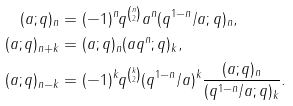Convert formula to latex. <formula><loc_0><loc_0><loc_500><loc_500>( a ; q ) _ { n } & = ( - 1 ) ^ { n } q ^ { \binom { n } { 2 } } a ^ { n } ( q ^ { 1 - n } / a ; q ) _ { n } , \\ ( a ; q ) _ { n + k } & = ( a ; q ) _ { n } ( a q ^ { n } ; q ) _ { k } , \\ ( a ; q ) _ { n - k } & = ( - 1 ) ^ { k } q ^ { \binom { k } { 2 } } ( q ^ { 1 - n } / a ) ^ { k } \frac { ( a ; q ) _ { n } } { ( q ^ { 1 - n } / a ; q ) _ { k } } .</formula> 